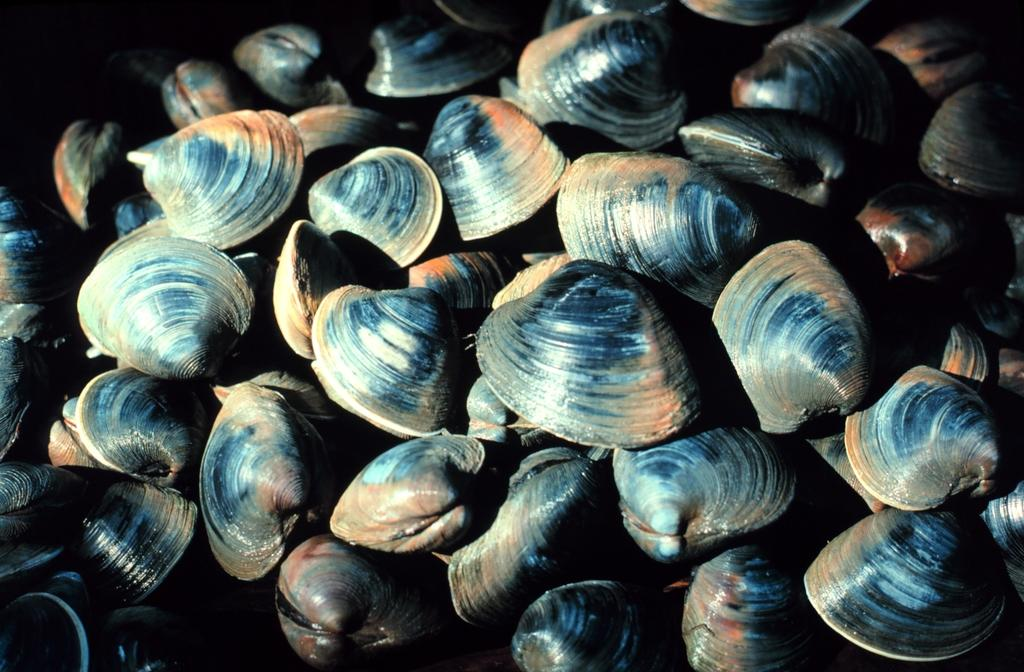What type of objects can be seen in the image? There are many shells in the image. Can you describe the appearance of the shells? The shells in the image have various shapes and sizes. What might be the origin of these shells? The shells in the image might have come from the ocean or a beach. What type of loaf can be seen in the image? There is no loaf present in the image; it only contains shells. 